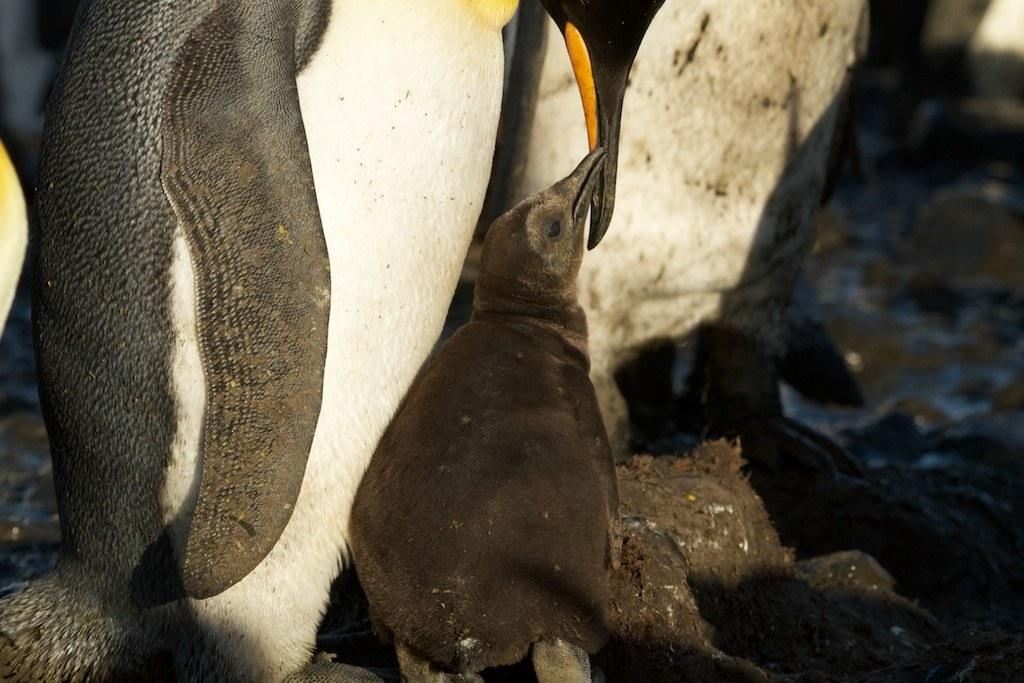What type of animal is in the picture? There is a penguin in the picture. Can you describe the penguin in the picture? There is a baby penguin in the picture. What type of prose can be heard in the background of the image? There is no prose or sound present in the image, as it is a still picture of a penguin and a baby penguin. 